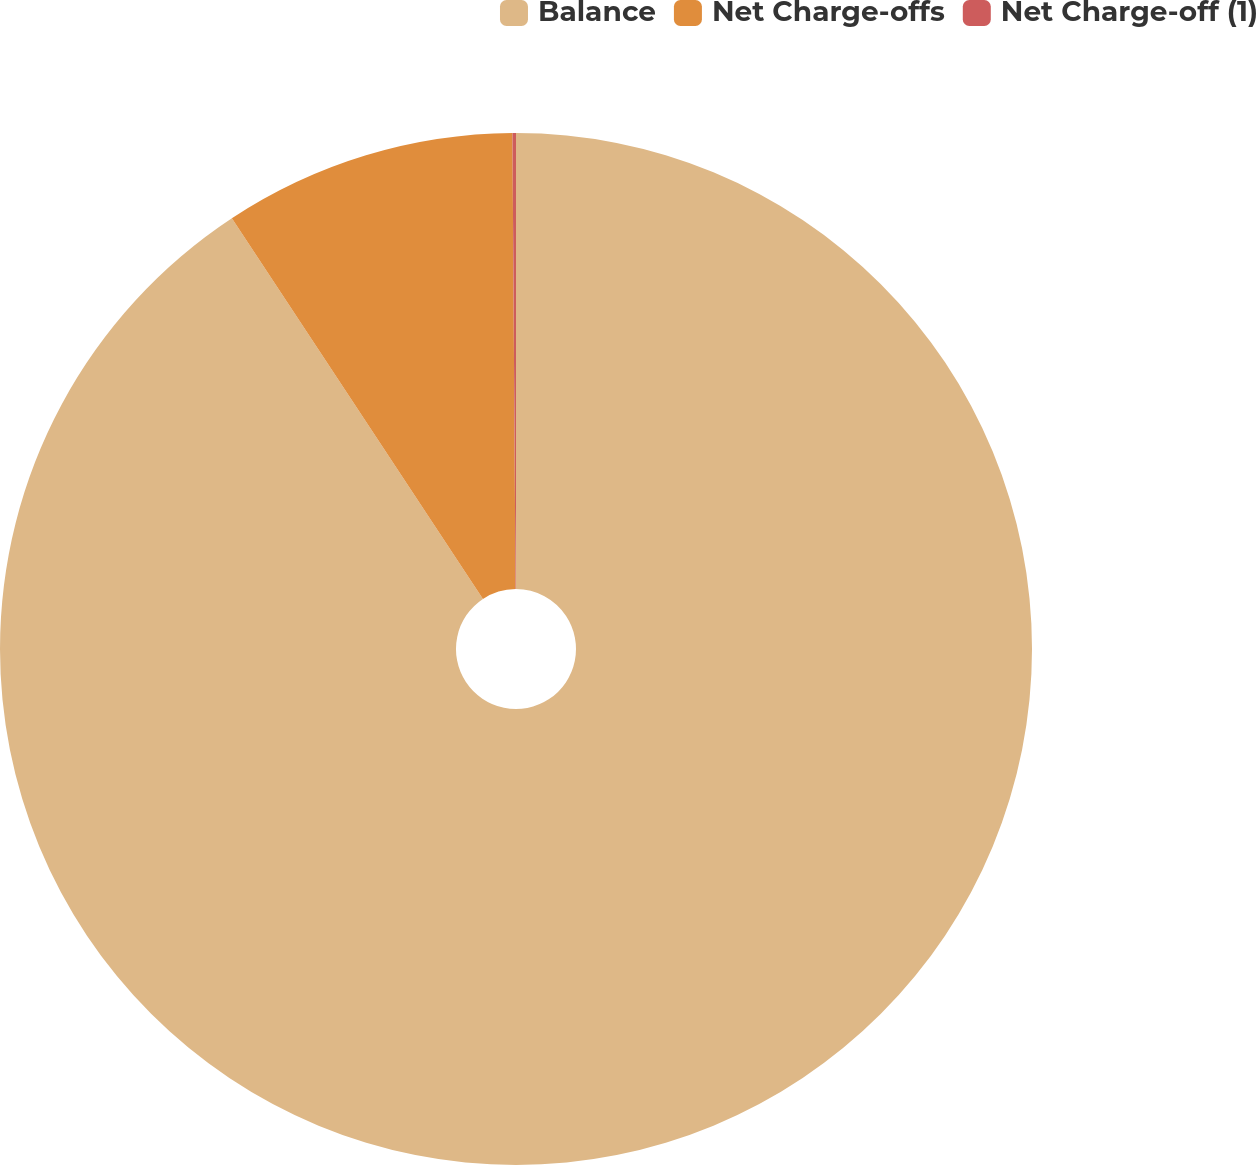Convert chart to OTSL. <chart><loc_0><loc_0><loc_500><loc_500><pie_chart><fcel>Balance<fcel>Net Charge-offs<fcel>Net Charge-off (1)<nl><fcel>90.71%<fcel>9.17%<fcel>0.11%<nl></chart> 